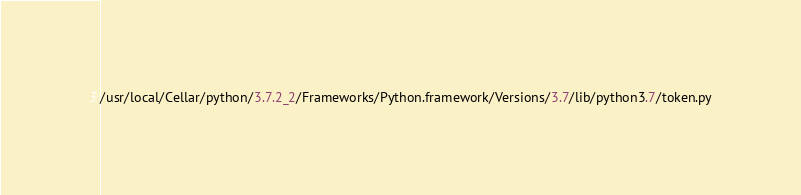<code> <loc_0><loc_0><loc_500><loc_500><_Python_>/usr/local/Cellar/python/3.7.2_2/Frameworks/Python.framework/Versions/3.7/lib/python3.7/token.py</code> 